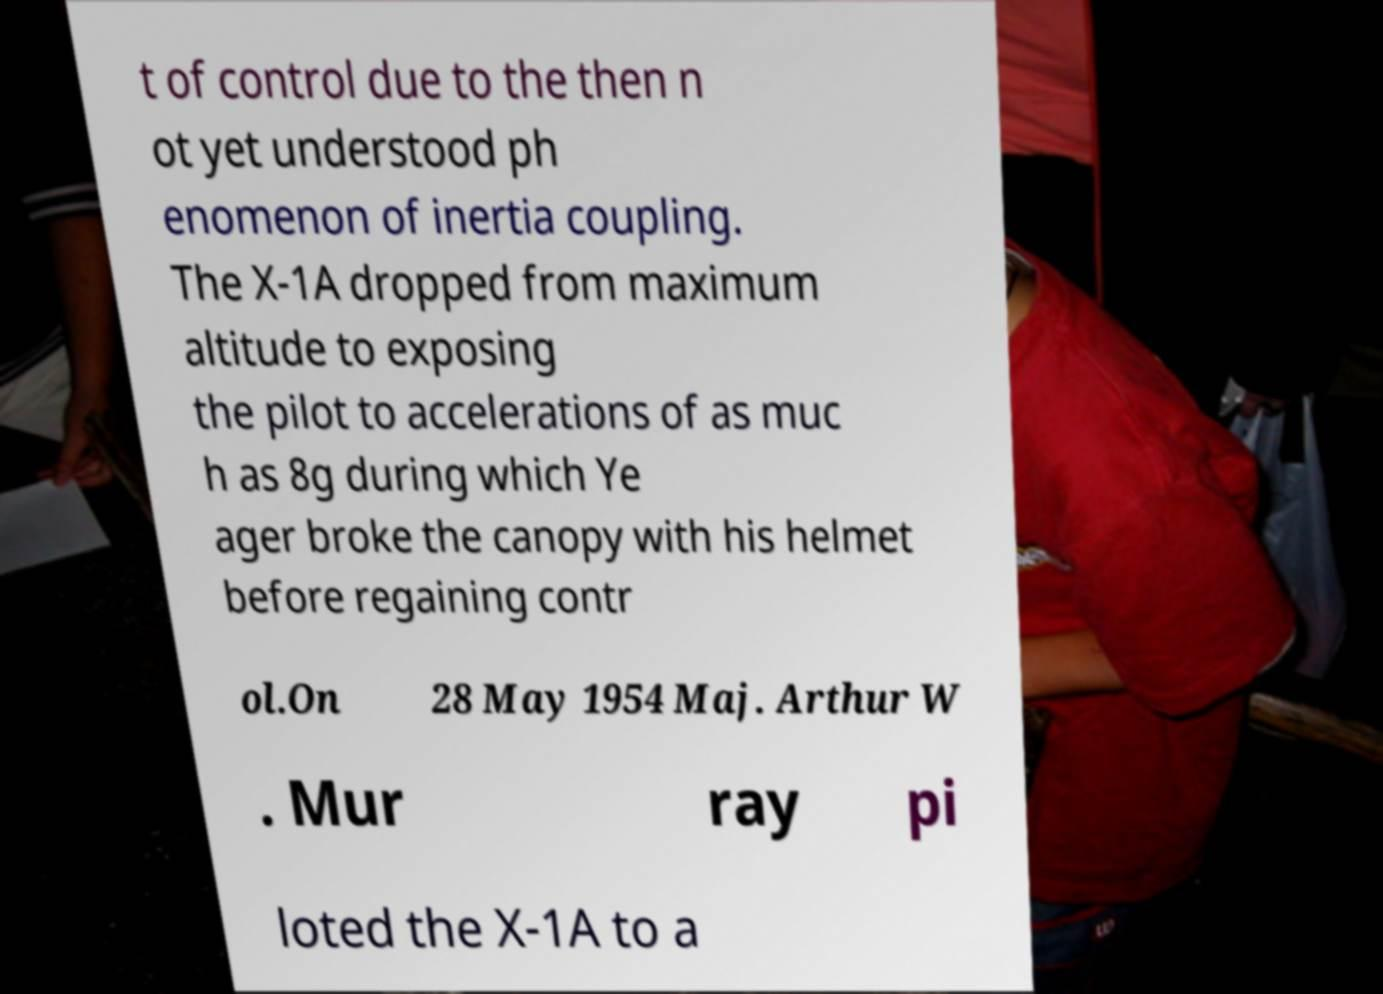Can you accurately transcribe the text from the provided image for me? t of control due to the then n ot yet understood ph enomenon of inertia coupling. The X-1A dropped from maximum altitude to exposing the pilot to accelerations of as muc h as 8g during which Ye ager broke the canopy with his helmet before regaining contr ol.On 28 May 1954 Maj. Arthur W . Mur ray pi loted the X-1A to a 